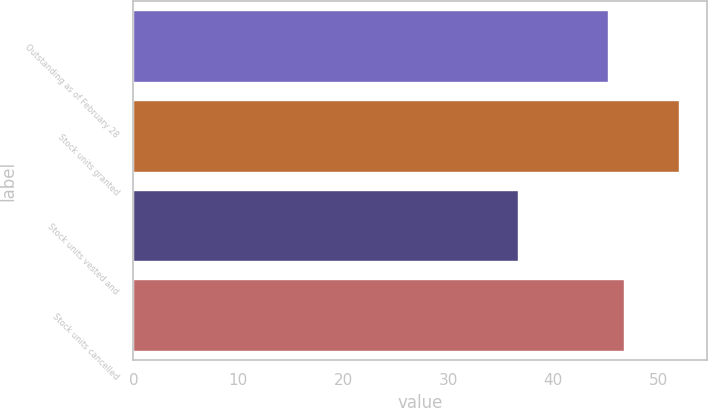Convert chart to OTSL. <chart><loc_0><loc_0><loc_500><loc_500><bar_chart><fcel>Outstanding as of February 28<fcel>Stock units granted<fcel>Stock units vested and<fcel>Stock units cancelled<nl><fcel>45.26<fcel>52.02<fcel>36.66<fcel>46.8<nl></chart> 